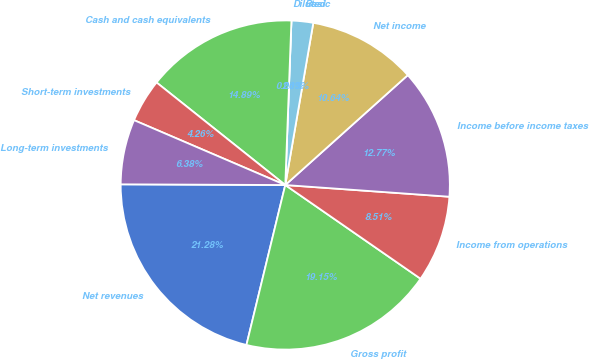Convert chart. <chart><loc_0><loc_0><loc_500><loc_500><pie_chart><fcel>Net revenues<fcel>Gross profit<fcel>Income from operations<fcel>Income before income taxes<fcel>Net income<fcel>Basic<fcel>Diluted<fcel>Cash and cash equivalents<fcel>Short-term investments<fcel>Long-term investments<nl><fcel>21.28%<fcel>19.15%<fcel>8.51%<fcel>12.77%<fcel>10.64%<fcel>2.13%<fcel>0.0%<fcel>14.89%<fcel>4.26%<fcel>6.38%<nl></chart> 